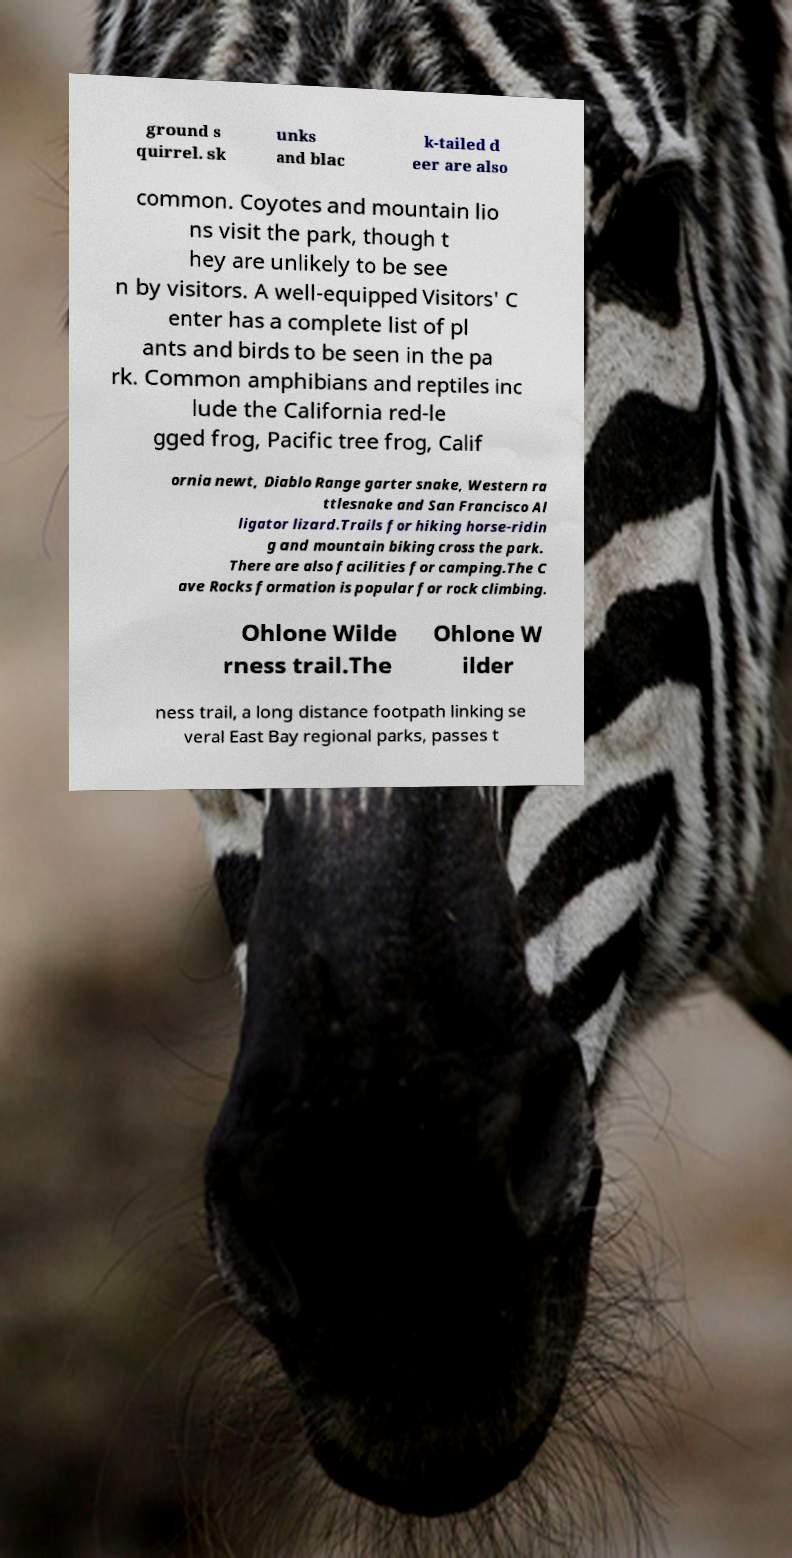Please identify and transcribe the text found in this image. ground s quirrel. sk unks and blac k-tailed d eer are also common. Coyotes and mountain lio ns visit the park, though t hey are unlikely to be see n by visitors. A well-equipped Visitors' C enter has a complete list of pl ants and birds to be seen in the pa rk. Common amphibians and reptiles inc lude the California red-le gged frog, Pacific tree frog, Calif ornia newt, Diablo Range garter snake, Western ra ttlesnake and San Francisco Al ligator lizard.Trails for hiking horse-ridin g and mountain biking cross the park. There are also facilities for camping.The C ave Rocks formation is popular for rock climbing. Ohlone Wilde rness trail.The Ohlone W ilder ness trail, a long distance footpath linking se veral East Bay regional parks, passes t 